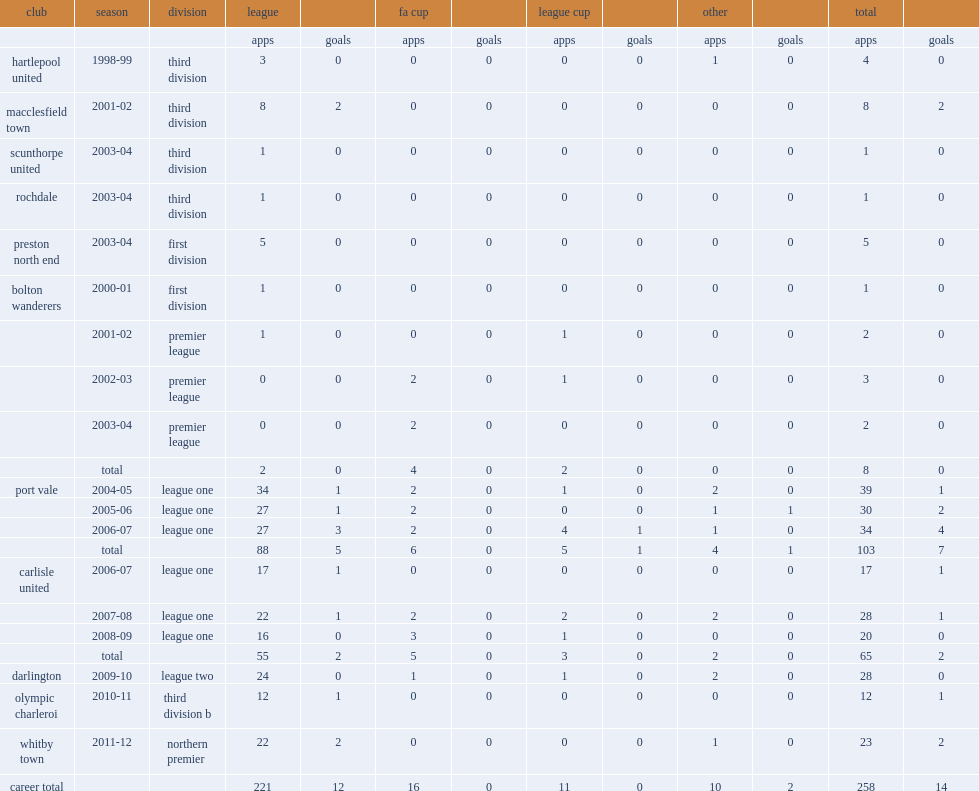In the 2003-04 season, what clubs was smith loaned out to? Scunthorpe united rochdale preston north end. 